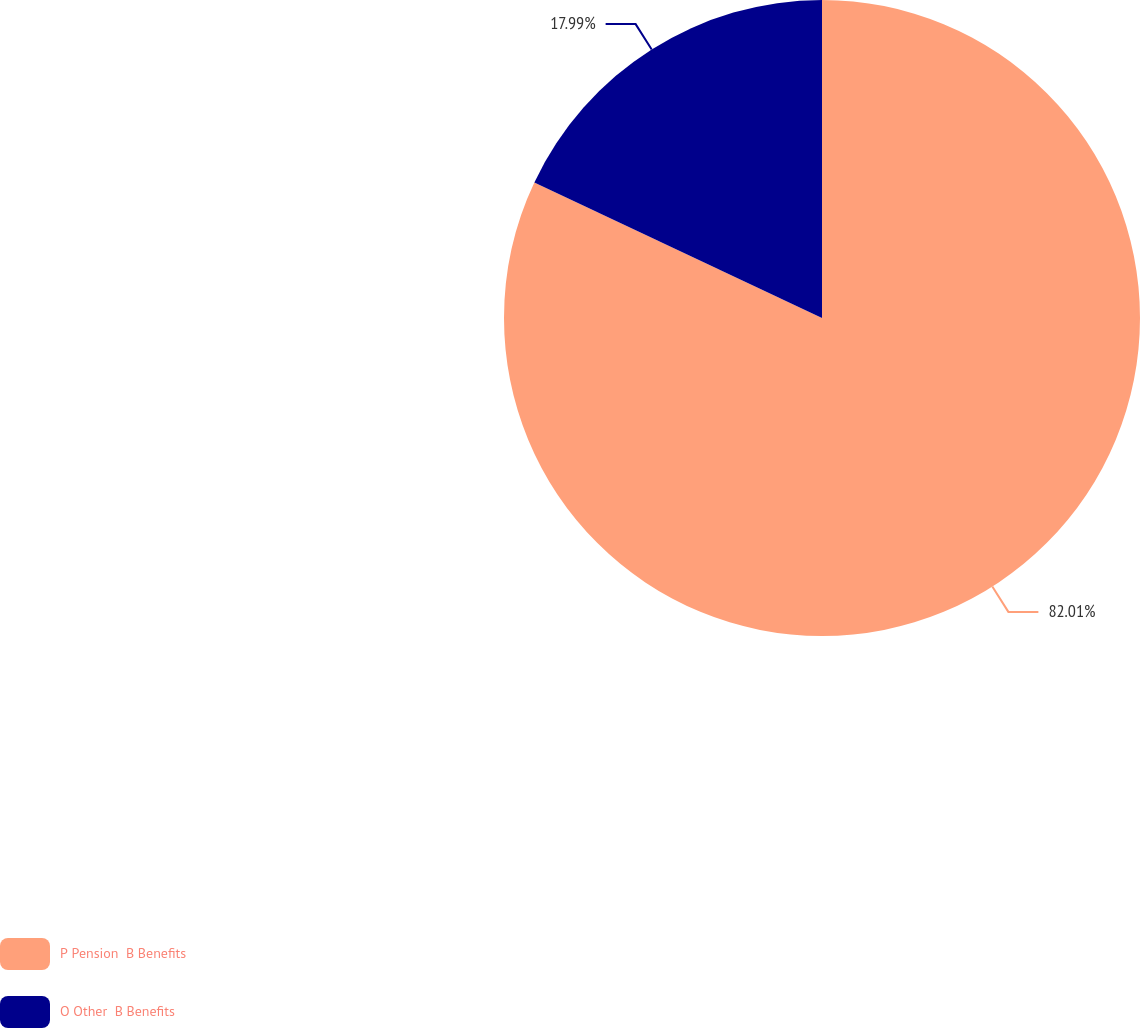<chart> <loc_0><loc_0><loc_500><loc_500><pie_chart><fcel>P Pension  B Benefits<fcel>O Other  B Benefits<nl><fcel>82.01%<fcel>17.99%<nl></chart> 